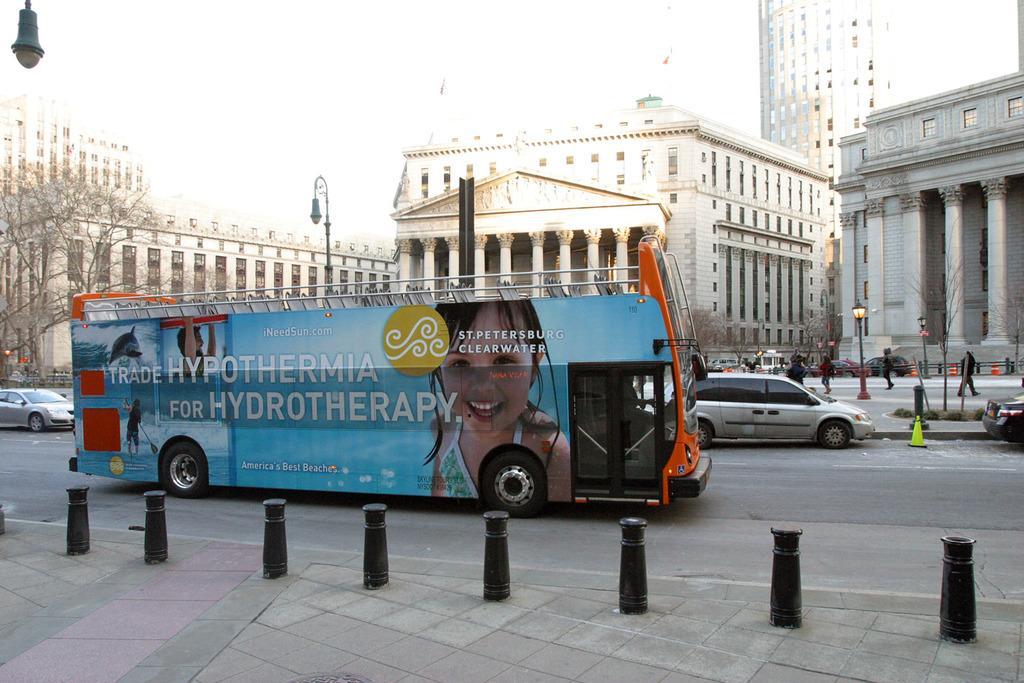How would you summarize this image in a sentence or two? In this image I can see many vehicles on the road. To the side of the road I can see the black color poles, traffic cones and light poles. In the background I can see few people, buildings, trees and the sky. 